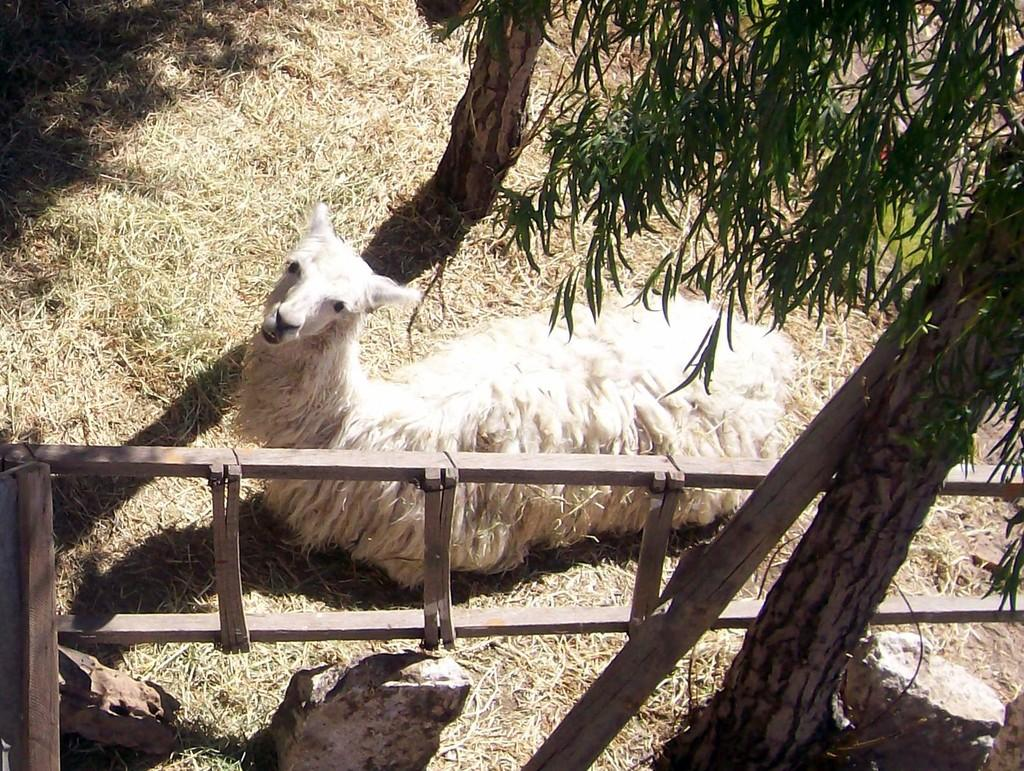What type of animal is in the picture? The type of animal cannot be determined from the provided facts. What is the animal doing in the picture? The animal is lying on the grass. What can be seen in the background of the picture? There are two trees on either side of the animal. What time does the clock in the picture show? There is no clock present in the image. How does the animal help the other animals in the picture? There is no indication of other animals in the picture, and the animal's actions cannot be determined from the provided facts. 